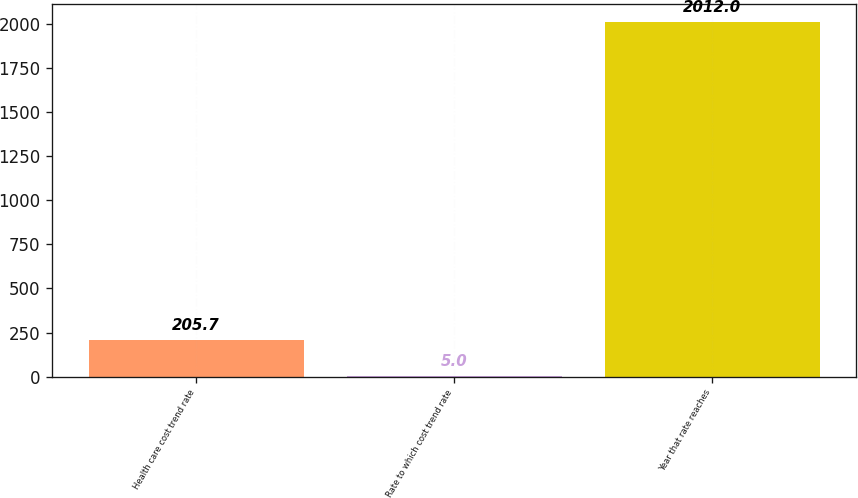Convert chart. <chart><loc_0><loc_0><loc_500><loc_500><bar_chart><fcel>Health care cost trend rate<fcel>Rate to which cost trend rate<fcel>Year that rate reaches<nl><fcel>205.7<fcel>5<fcel>2012<nl></chart> 